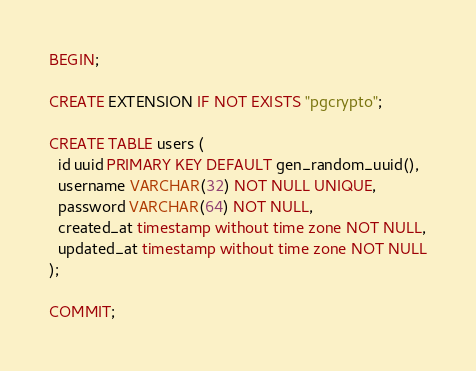<code> <loc_0><loc_0><loc_500><loc_500><_SQL_>BEGIN;

CREATE EXTENSION IF NOT EXISTS "pgcrypto";

CREATE TABLE users (
  id uuid PRIMARY KEY DEFAULT gen_random_uuid(),
  username VARCHAR(32) NOT NULL UNIQUE,
  password VARCHAR(64) NOT NULL,
  created_at timestamp without time zone NOT NULL,
  updated_at timestamp without time zone NOT NULL
);

COMMIT;</code> 